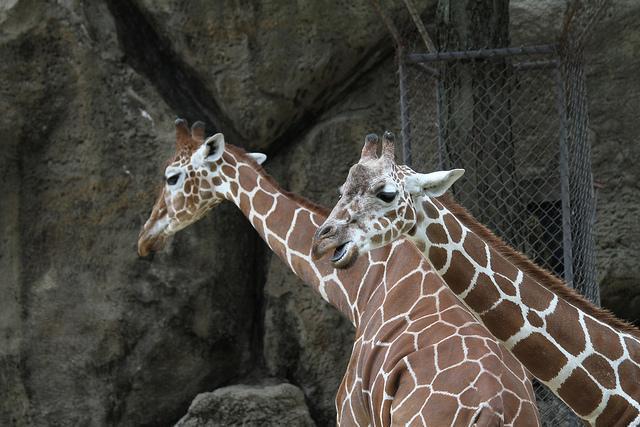How many giraffes are there?
Give a very brief answer. 2. How many giraffes can be seen?
Give a very brief answer. 2. How many cats do you see?
Give a very brief answer. 0. 